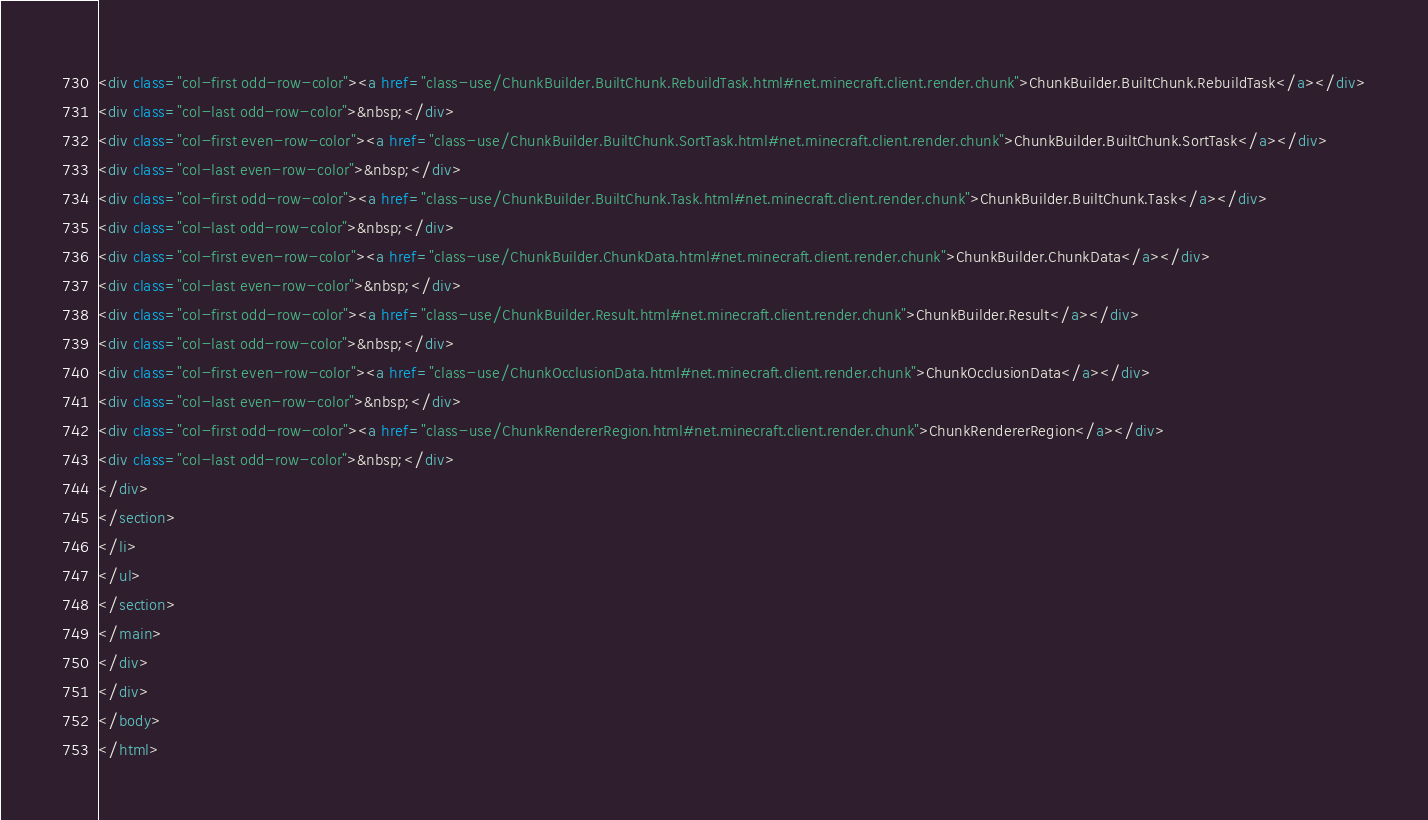Convert code to text. <code><loc_0><loc_0><loc_500><loc_500><_HTML_><div class="col-first odd-row-color"><a href="class-use/ChunkBuilder.BuiltChunk.RebuildTask.html#net.minecraft.client.render.chunk">ChunkBuilder.BuiltChunk.RebuildTask</a></div>
<div class="col-last odd-row-color">&nbsp;</div>
<div class="col-first even-row-color"><a href="class-use/ChunkBuilder.BuiltChunk.SortTask.html#net.minecraft.client.render.chunk">ChunkBuilder.BuiltChunk.SortTask</a></div>
<div class="col-last even-row-color">&nbsp;</div>
<div class="col-first odd-row-color"><a href="class-use/ChunkBuilder.BuiltChunk.Task.html#net.minecraft.client.render.chunk">ChunkBuilder.BuiltChunk.Task</a></div>
<div class="col-last odd-row-color">&nbsp;</div>
<div class="col-first even-row-color"><a href="class-use/ChunkBuilder.ChunkData.html#net.minecraft.client.render.chunk">ChunkBuilder.ChunkData</a></div>
<div class="col-last even-row-color">&nbsp;</div>
<div class="col-first odd-row-color"><a href="class-use/ChunkBuilder.Result.html#net.minecraft.client.render.chunk">ChunkBuilder.Result</a></div>
<div class="col-last odd-row-color">&nbsp;</div>
<div class="col-first even-row-color"><a href="class-use/ChunkOcclusionData.html#net.minecraft.client.render.chunk">ChunkOcclusionData</a></div>
<div class="col-last even-row-color">&nbsp;</div>
<div class="col-first odd-row-color"><a href="class-use/ChunkRendererRegion.html#net.minecraft.client.render.chunk">ChunkRendererRegion</a></div>
<div class="col-last odd-row-color">&nbsp;</div>
</div>
</section>
</li>
</ul>
</section>
</main>
</div>
</div>
</body>
</html>
</code> 